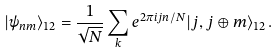Convert formula to latex. <formula><loc_0><loc_0><loc_500><loc_500>| \psi _ { n m } \rangle _ { 1 2 } = \frac { 1 } { \sqrt { N } } \sum _ { k } e ^ { 2 \pi i j n / N } | j , j \oplus m \rangle _ { 1 2 } \, .</formula> 